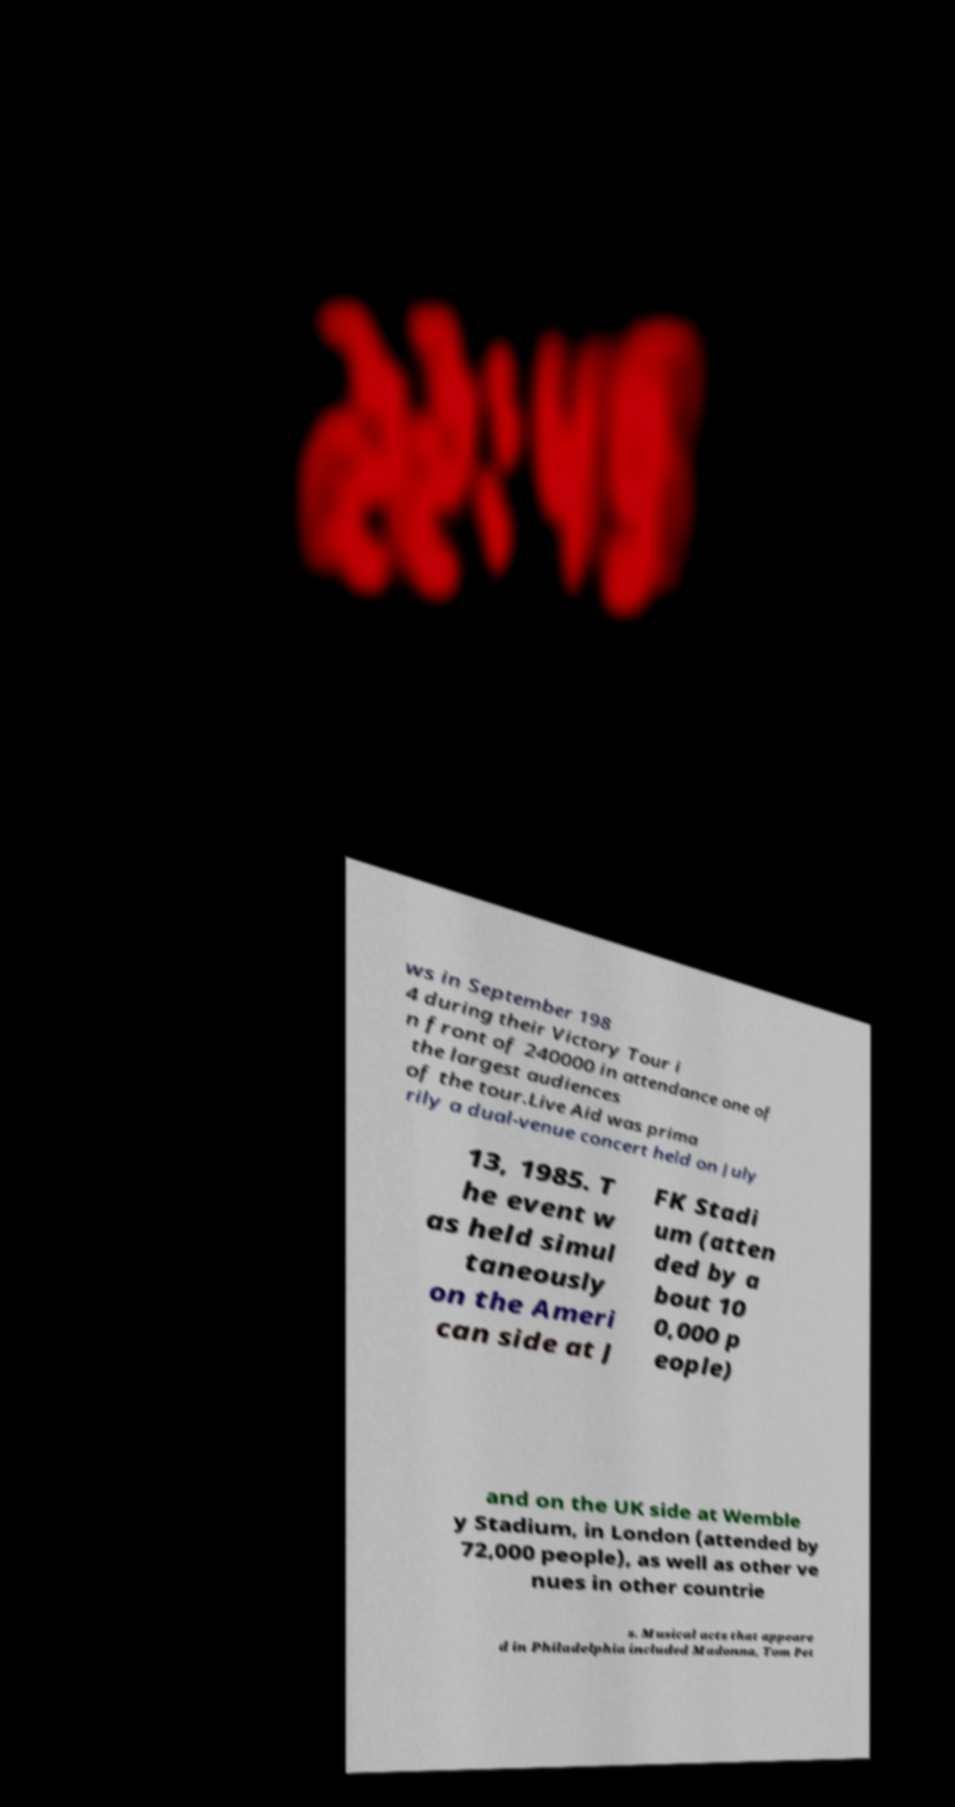Please read and relay the text visible in this image. What does it say? ws in September 198 4 during their Victory Tour i n front of 240000 in attendance one of the largest audiences of the tour.Live Aid was prima rily a dual-venue concert held on July 13, 1985. T he event w as held simul taneously on the Ameri can side at J FK Stadi um (atten ded by a bout 10 0,000 p eople) and on the UK side at Wemble y Stadium, in London (attended by 72,000 people), as well as other ve nues in other countrie s. Musical acts that appeare d in Philadelphia included Madonna, Tom Pet 